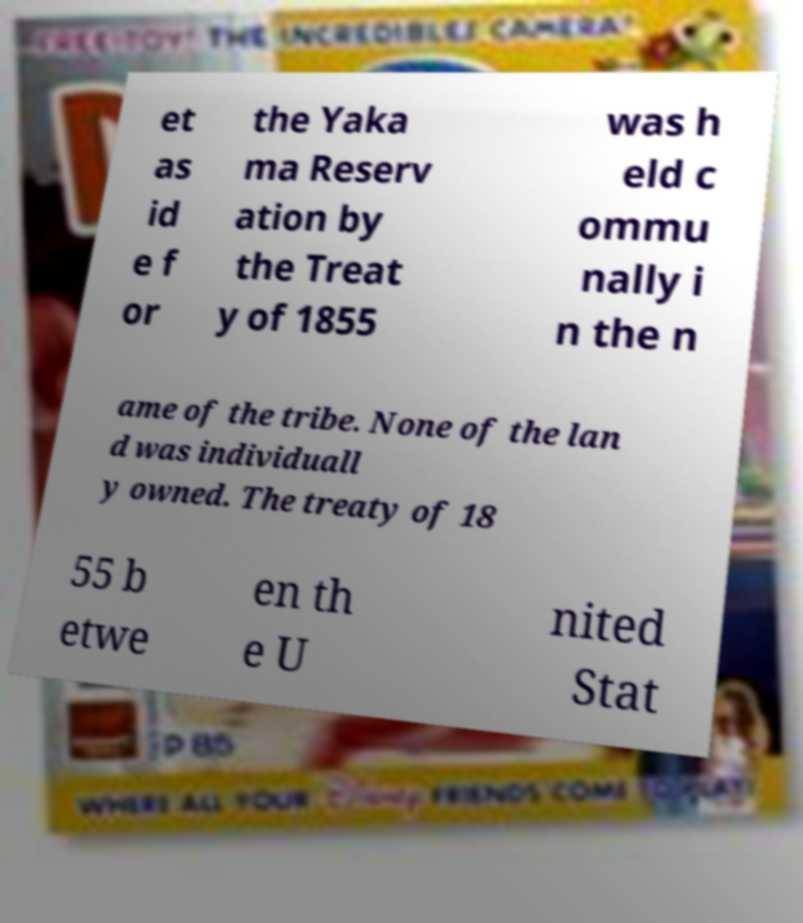Could you assist in decoding the text presented in this image and type it out clearly? et as id e f or the Yaka ma Reserv ation by the Treat y of 1855 was h eld c ommu nally i n the n ame of the tribe. None of the lan d was individuall y owned. The treaty of 18 55 b etwe en th e U nited Stat 